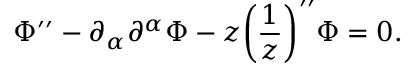Convert formula to latex. <formula><loc_0><loc_0><loc_500><loc_500>\Phi ^ { \prime \prime } - \partial _ { \alpha } \partial ^ { \alpha } \Phi - z \left ( \frac { 1 } { z } \right ) ^ { \prime \prime } \Phi = 0 .</formula> 